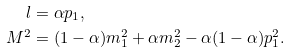Convert formula to latex. <formula><loc_0><loc_0><loc_500><loc_500>l & = \alpha p _ { 1 } , \\ M ^ { 2 } & = ( 1 - \alpha ) m _ { 1 } ^ { 2 } + \alpha m _ { 2 } ^ { 2 } - \alpha ( 1 - \alpha ) p _ { 1 } ^ { 2 } .</formula> 